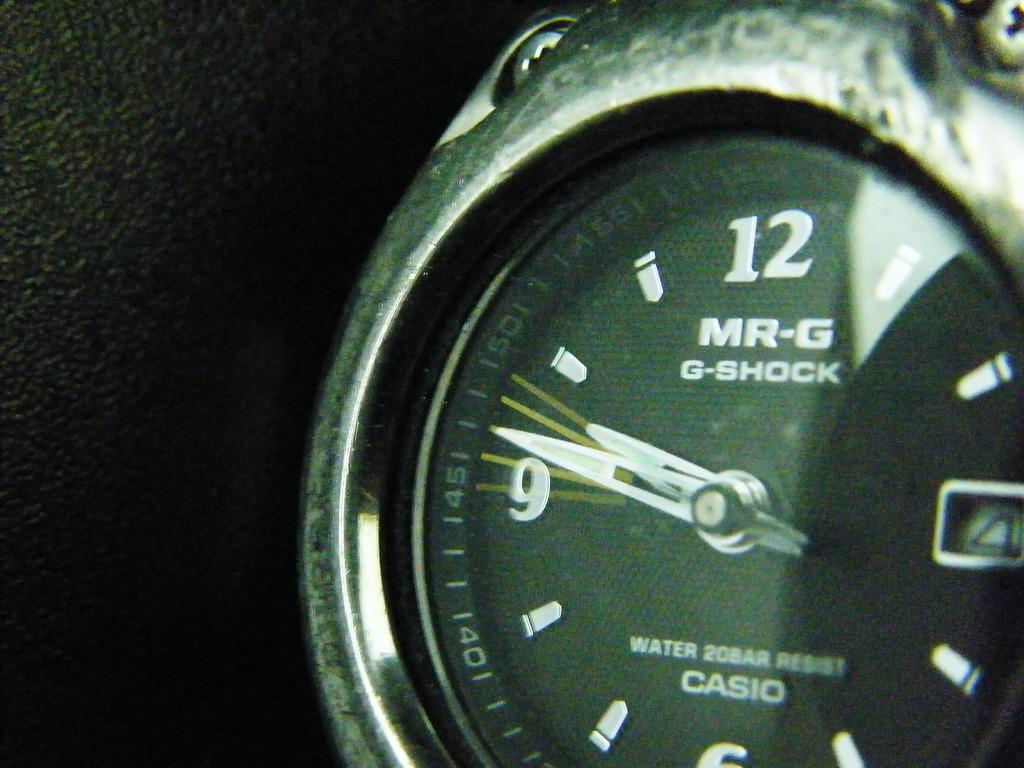What is the brand of the watch?
Keep it short and to the point. Casio. What type of watch is this?
Your answer should be very brief. Casio. 